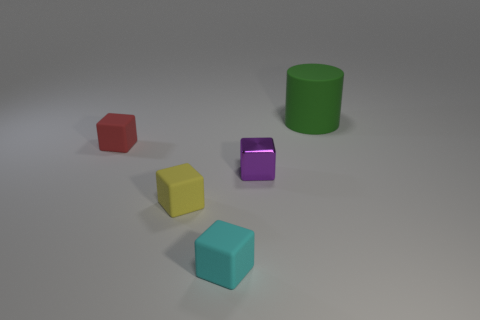Is the shape of the matte thing that is right of the shiny object the same as  the yellow thing?
Your answer should be compact. No. Are there more green matte cylinders that are to the left of the matte cylinder than big green blocks?
Your answer should be very brief. No. What color is the metal block that is the same size as the yellow rubber cube?
Your answer should be compact. Purple. What number of objects are either blocks to the left of the cyan cube or cyan rubber things?
Make the answer very short. 3. What material is the cube that is right of the rubber cube that is to the right of the small yellow rubber block?
Offer a terse response. Metal. Are there any purple blocks that have the same material as the green cylinder?
Provide a short and direct response. No. There is a matte cube that is behind the tiny purple cube; is there a tiny cyan rubber thing that is left of it?
Your response must be concise. No. What is the small block that is on the right side of the cyan object made of?
Offer a very short reply. Metal. Is the cyan object the same shape as the green object?
Offer a terse response. No. There is a thing behind the small cube behind the tiny thing to the right of the tiny cyan thing; what is its color?
Keep it short and to the point. Green. 